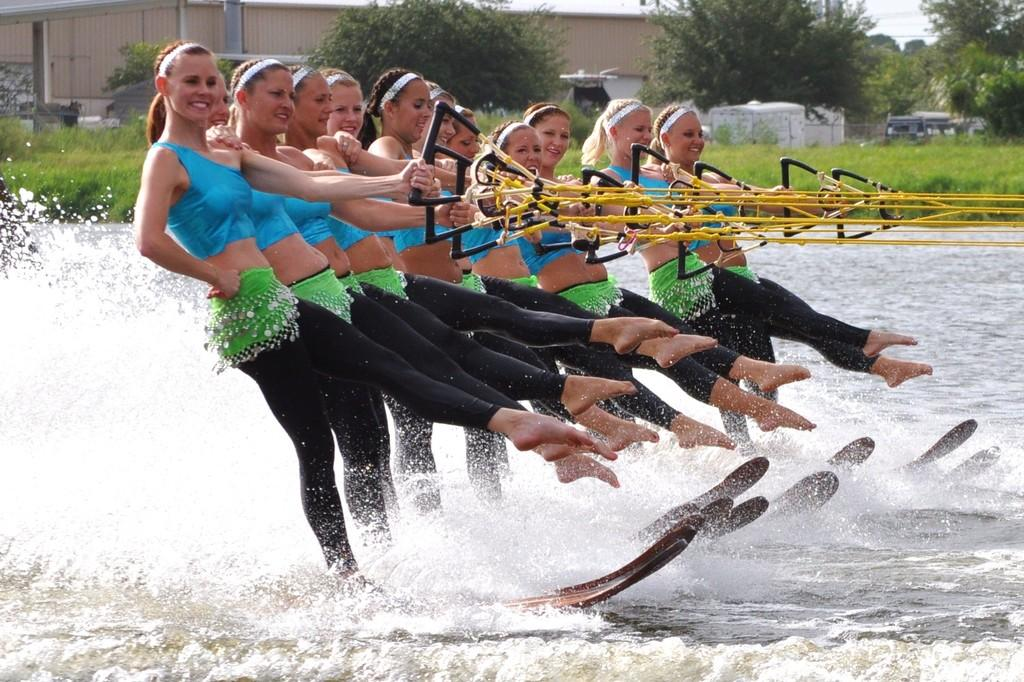What is happening in the image involving the group of women? The women are wakeboarding on the water, holding surf ropes. What are the women using to hold onto while wakeboarding? The women are holding surf ropes. What can be seen in the background of the image? There are buildings, trees, houses, and plants in the background of the image. How many stories tall is the fifth building in the image? There is no mention of a fifth building in the image, and therefore no information about its height or number of stories. 